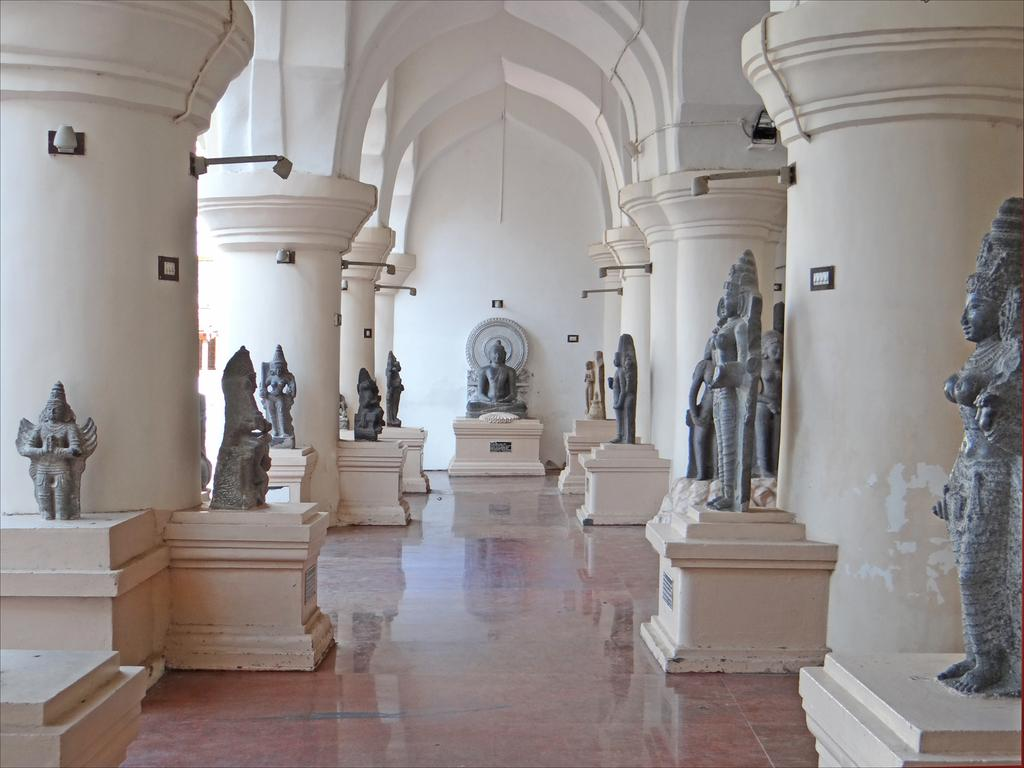What type of location is depicted in the image? The image shows an inside view of a corridor. What objects can be seen in the corridor? There are black statues in the image. How are the statues positioned in the corridor? The statues are placed on concrete tables. What architectural feature is visible in the image? There are arch design pillars visible in the image. Can you see any lake in the image? No, there is no lake present in the image. What type of art is displayed on the walls in the image? The provided facts do not mention any art displayed on the walls in the image. 